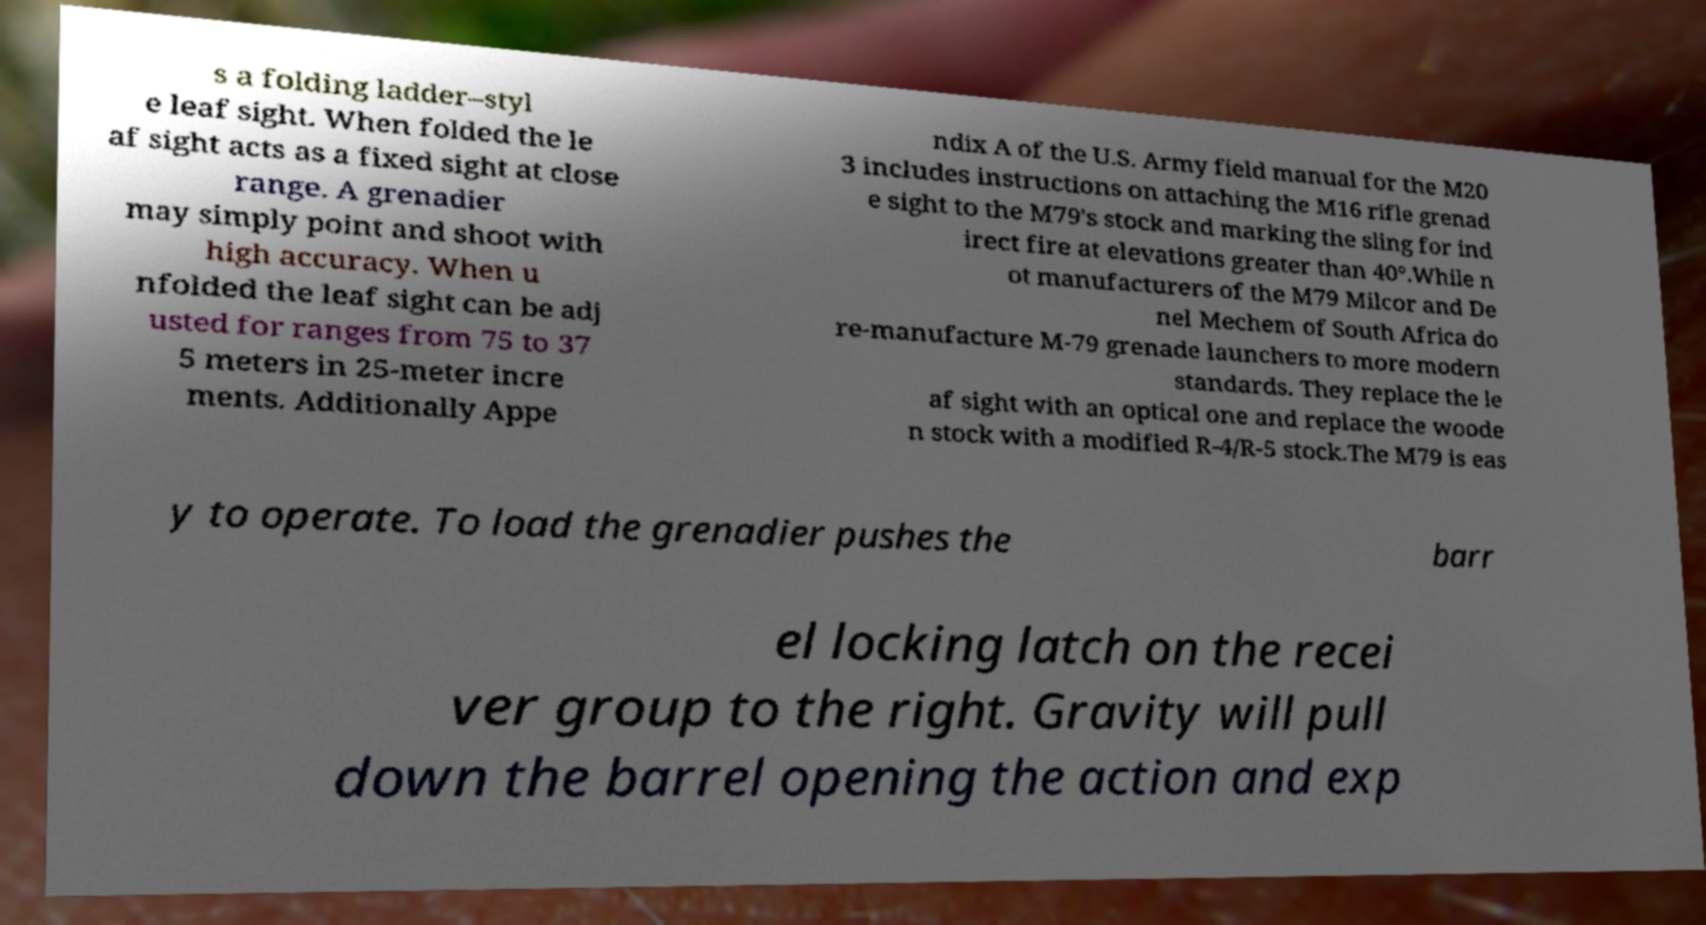I need the written content from this picture converted into text. Can you do that? s a folding ladder–styl e leaf sight. When folded the le af sight acts as a fixed sight at close range. A grenadier may simply point and shoot with high accuracy. When u nfolded the leaf sight can be adj usted for ranges from 75 to 37 5 meters in 25-meter incre ments. Additionally Appe ndix A of the U.S. Army field manual for the M20 3 includes instructions on attaching the M16 rifle grenad e sight to the M79's stock and marking the sling for ind irect fire at elevations greater than 40°.While n ot manufacturers of the M79 Milcor and De nel Mechem of South Africa do re-manufacture M-79 grenade launchers to more modern standards. They replace the le af sight with an optical one and replace the woode n stock with a modified R-4/R-5 stock.The M79 is eas y to operate. To load the grenadier pushes the barr el locking latch on the recei ver group to the right. Gravity will pull down the barrel opening the action and exp 